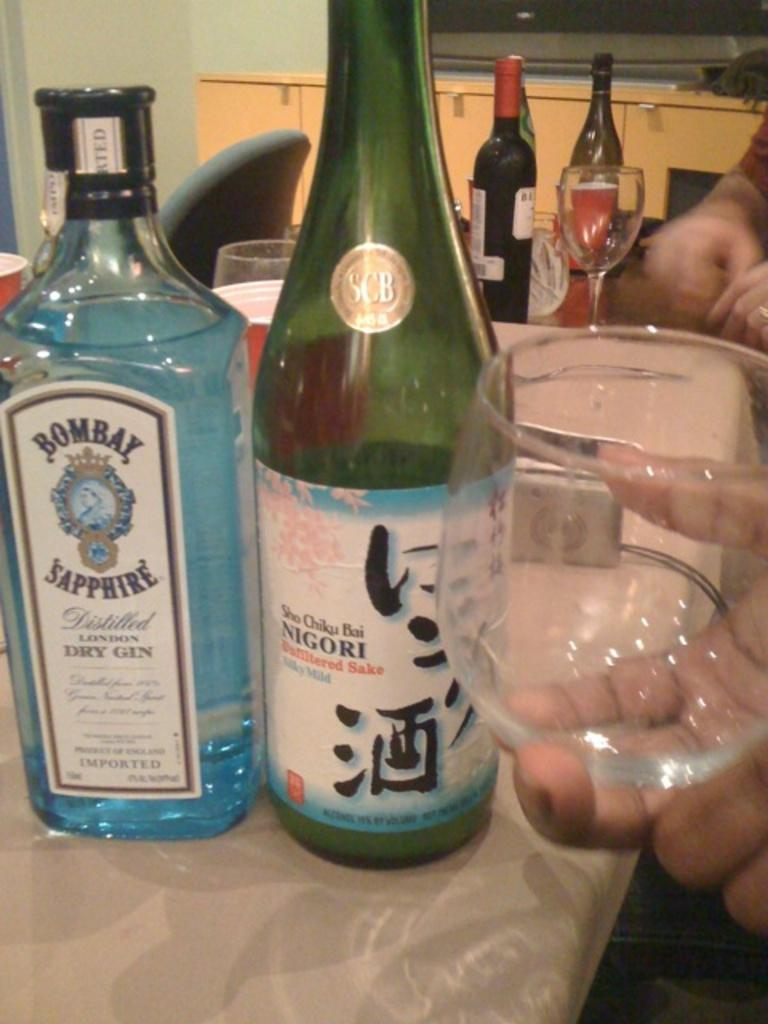What piece of furniture is in the image? There is a table in the image. What is on the table? A wine bottle and a glass are on the table. Who is in the image? There is a man in the image. What is the man holding? The man is holding a glass. Where is the man positioned in the image? The man is on the right side of the image. Can you see any crayons or dolls near the lake in the image? There is no lake, crayons, or dolls present in the image. 